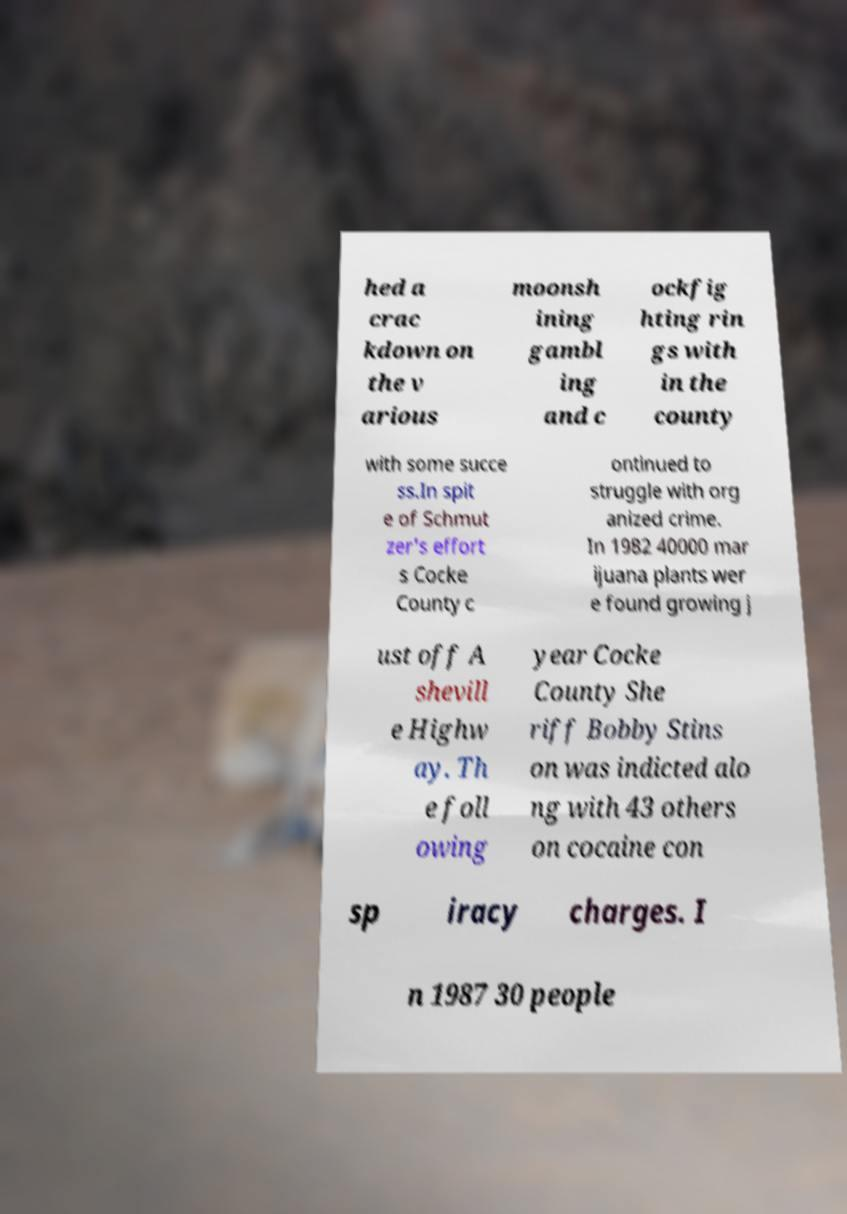For documentation purposes, I need the text within this image transcribed. Could you provide that? hed a crac kdown on the v arious moonsh ining gambl ing and c ockfig hting rin gs with in the county with some succe ss.In spit e of Schmut zer's effort s Cocke County c ontinued to struggle with org anized crime. In 1982 40000 mar ijuana plants wer e found growing j ust off A shevill e Highw ay. Th e foll owing year Cocke County She riff Bobby Stins on was indicted alo ng with 43 others on cocaine con sp iracy charges. I n 1987 30 people 